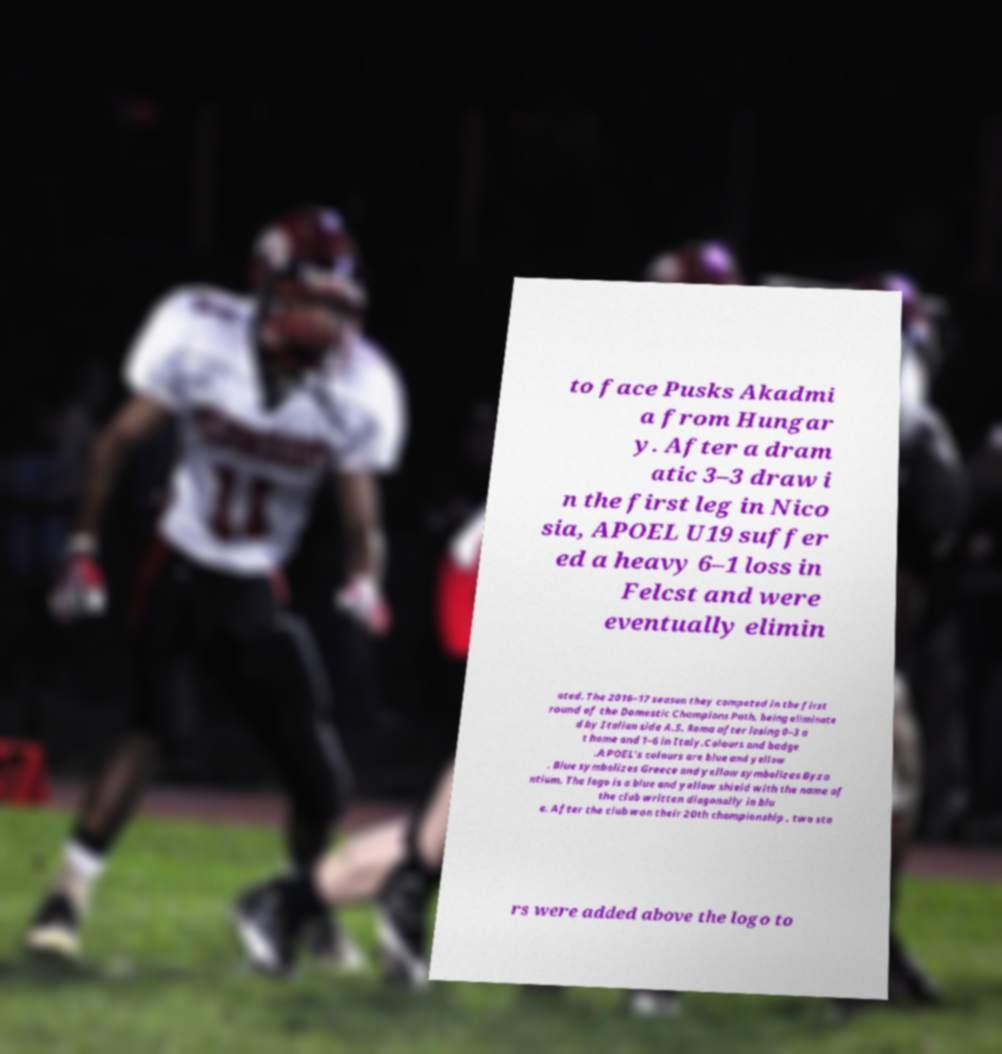Please read and relay the text visible in this image. What does it say? to face Pusks Akadmi a from Hungar y. After a dram atic 3–3 draw i n the first leg in Nico sia, APOEL U19 suffer ed a heavy 6–1 loss in Felcst and were eventually elimin ated. The 2016–17 season they competed in the first round of the Domestic Champions Path, being eliminate d by Italian side A.S. Roma after losing 0–3 a t home and 1–6 in Italy.Colours and badge .APOEL's colours are blue and yellow . Blue symbolizes Greece and yellow symbolizes Byza ntium. The logo is a blue and yellow shield with the name of the club written diagonally in blu e. After the club won their 20th championship , two sta rs were added above the logo to 